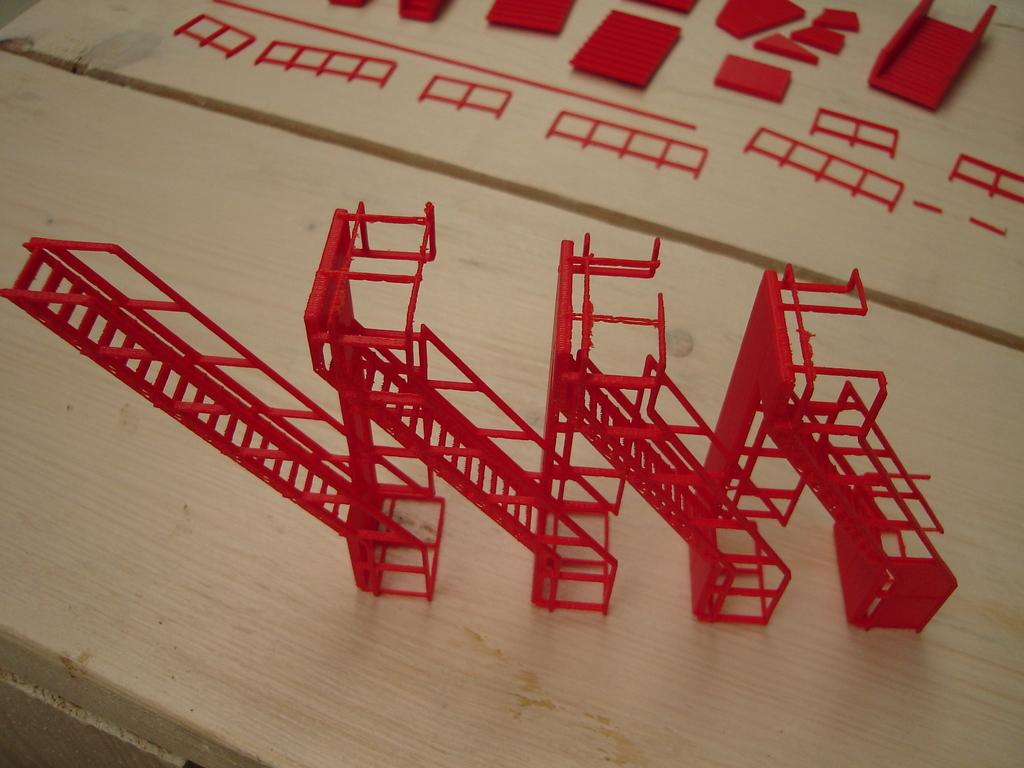What is the main object on the wooden surface in the image? There is a staircase model on a wooden surface in the image. What color is the staircase model? The staircase model is in red color. Can you describe the parts of the staircase model? The parts of the staircase model are visible in the image. What type of car can be seen driving on the trail in the image? There is no car or trail present in the image; it features a red staircase model on a wooden surface. 